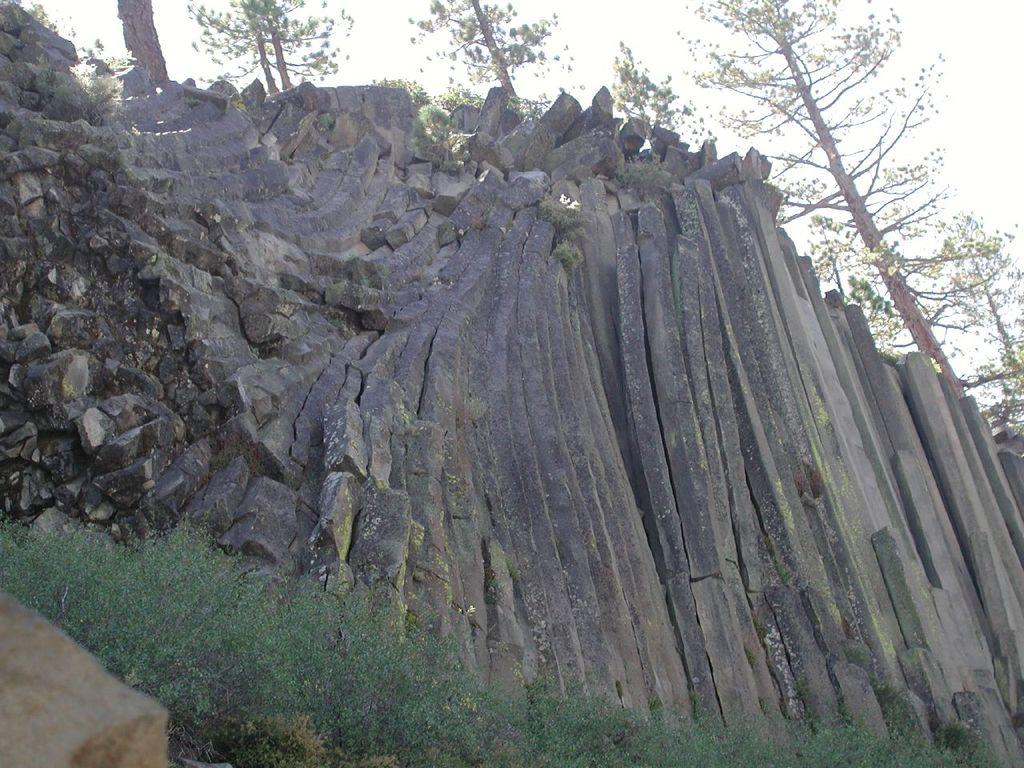What is the main subject in the center of the image? There are rocks in the center of the image. What type of vegetation can be seen in the image? There are trees in the image. What type of ground cover is present at the bottom of the image? There is grass at the bottom of the image. How many tails can be seen on the beetle in the image? There is no beetle present in the image, so it is not possible to determine the number of tails. 